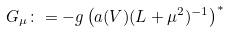<formula> <loc_0><loc_0><loc_500><loc_500>G _ { \mu } \colon = - g \left ( a ( V ) ( L + \mu ^ { 2 } ) ^ { - 1 } \right ) ^ { * }</formula> 